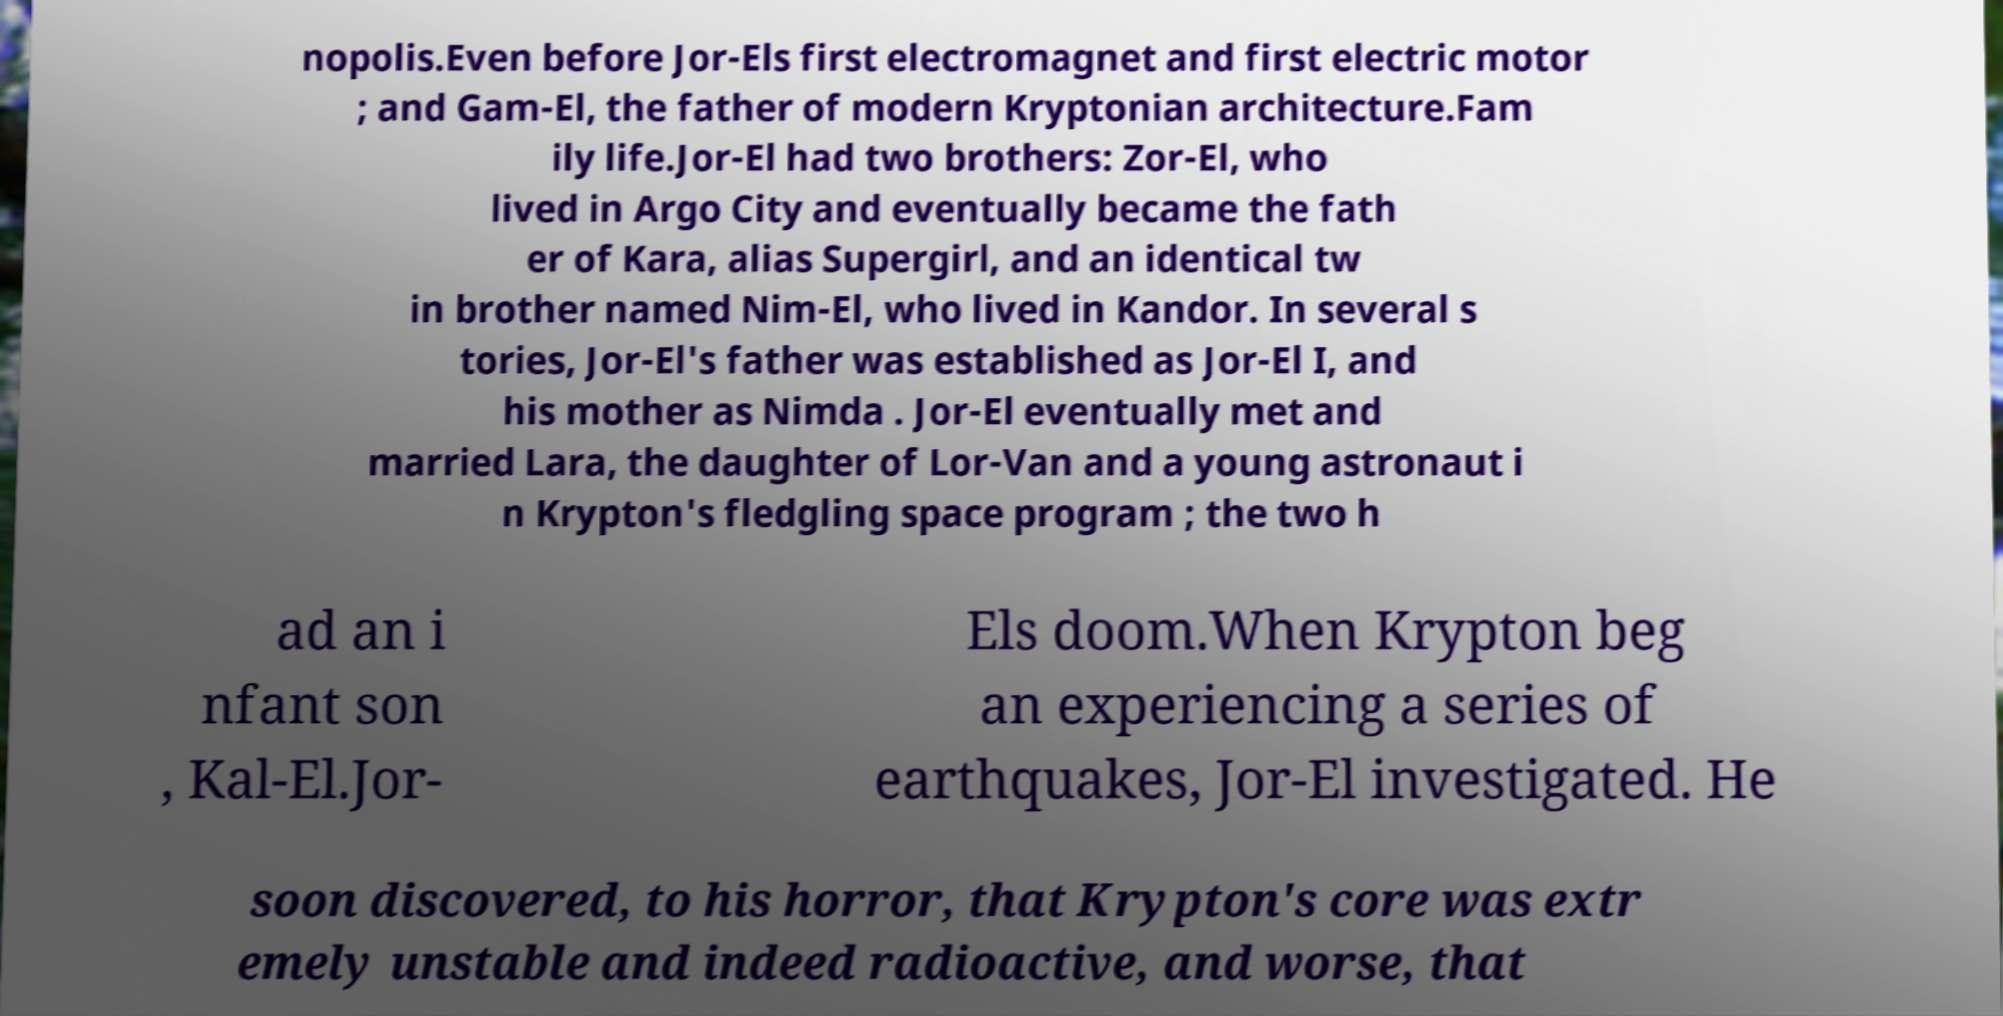Please identify and transcribe the text found in this image. nopolis.Even before Jor-Els first electromagnet and first electric motor ; and Gam-El, the father of modern Kryptonian architecture.Fam ily life.Jor-El had two brothers: Zor-El, who lived in Argo City and eventually became the fath er of Kara, alias Supergirl, and an identical tw in brother named Nim-El, who lived in Kandor. In several s tories, Jor-El's father was established as Jor-El I, and his mother as Nimda . Jor-El eventually met and married Lara, the daughter of Lor-Van and a young astronaut i n Krypton's fledgling space program ; the two h ad an i nfant son , Kal-El.Jor- Els doom.When Krypton beg an experiencing a series of earthquakes, Jor-El investigated. He soon discovered, to his horror, that Krypton's core was extr emely unstable and indeed radioactive, and worse, that 